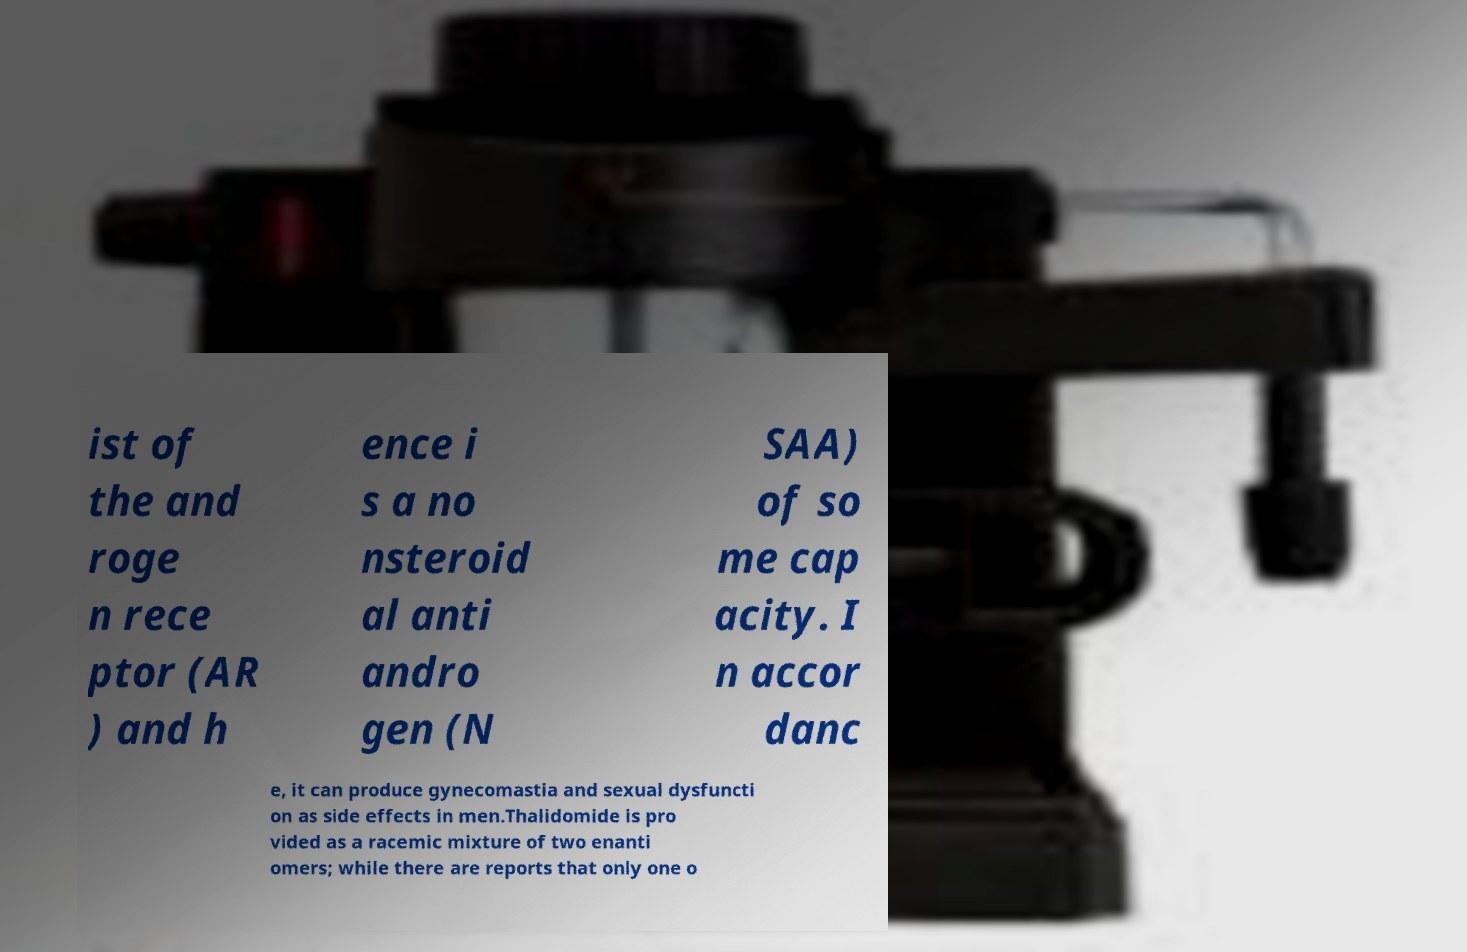Can you accurately transcribe the text from the provided image for me? ist of the and roge n rece ptor (AR ) and h ence i s a no nsteroid al anti andro gen (N SAA) of so me cap acity. I n accor danc e, it can produce gynecomastia and sexual dysfuncti on as side effects in men.Thalidomide is pro vided as a racemic mixture of two enanti omers; while there are reports that only one o 